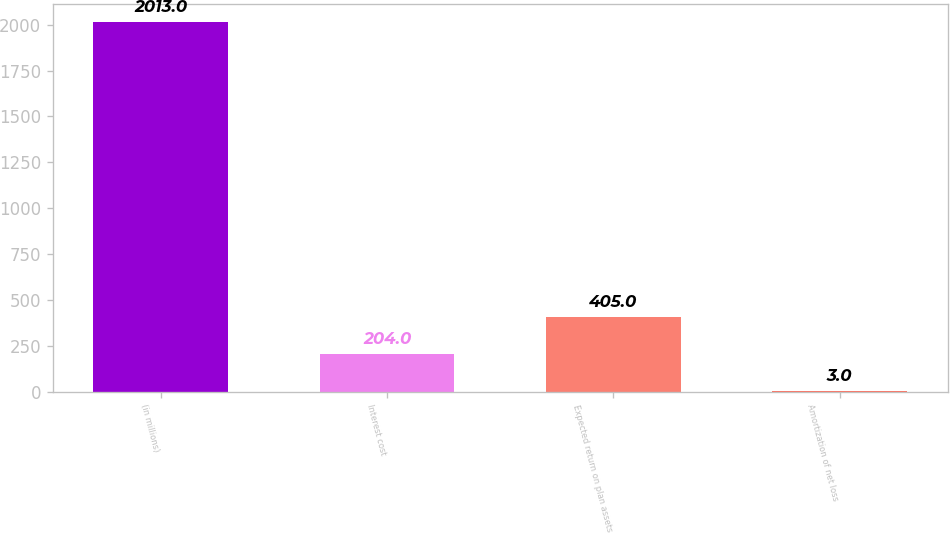Convert chart to OTSL. <chart><loc_0><loc_0><loc_500><loc_500><bar_chart><fcel>(in millions)<fcel>Interest cost<fcel>Expected return on plan assets<fcel>Amortization of net loss<nl><fcel>2013<fcel>204<fcel>405<fcel>3<nl></chart> 